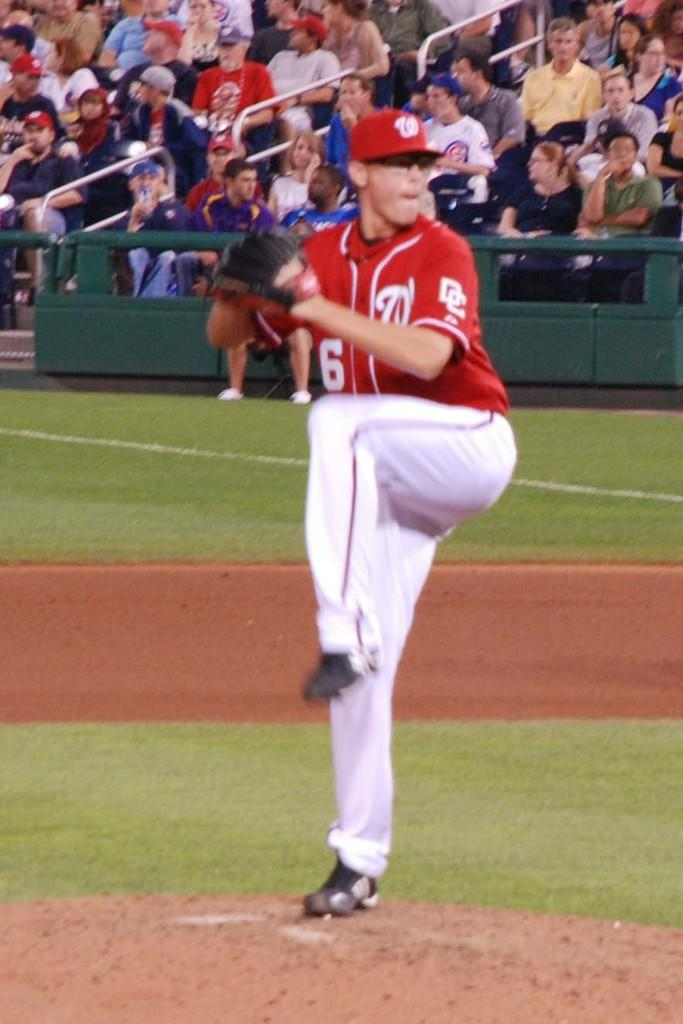<image>
Provide a brief description of the given image. A pitcher, wearing a red jersey with the initials "DC" on the sleeve, gets ready to throw. 